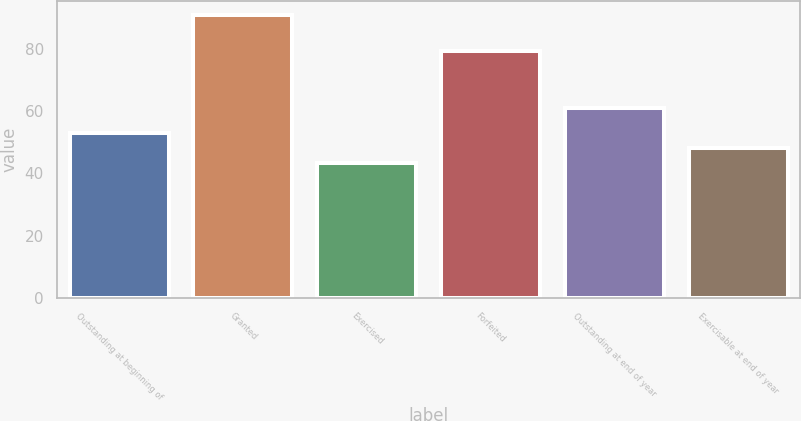Convert chart. <chart><loc_0><loc_0><loc_500><loc_500><bar_chart><fcel>Outstanding at beginning of<fcel>Granted<fcel>Exercised<fcel>Forfeited<fcel>Outstanding at end of year<fcel>Exercisable at end of year<nl><fcel>52.83<fcel>90.82<fcel>43.33<fcel>79.25<fcel>60.82<fcel>48.08<nl></chart> 